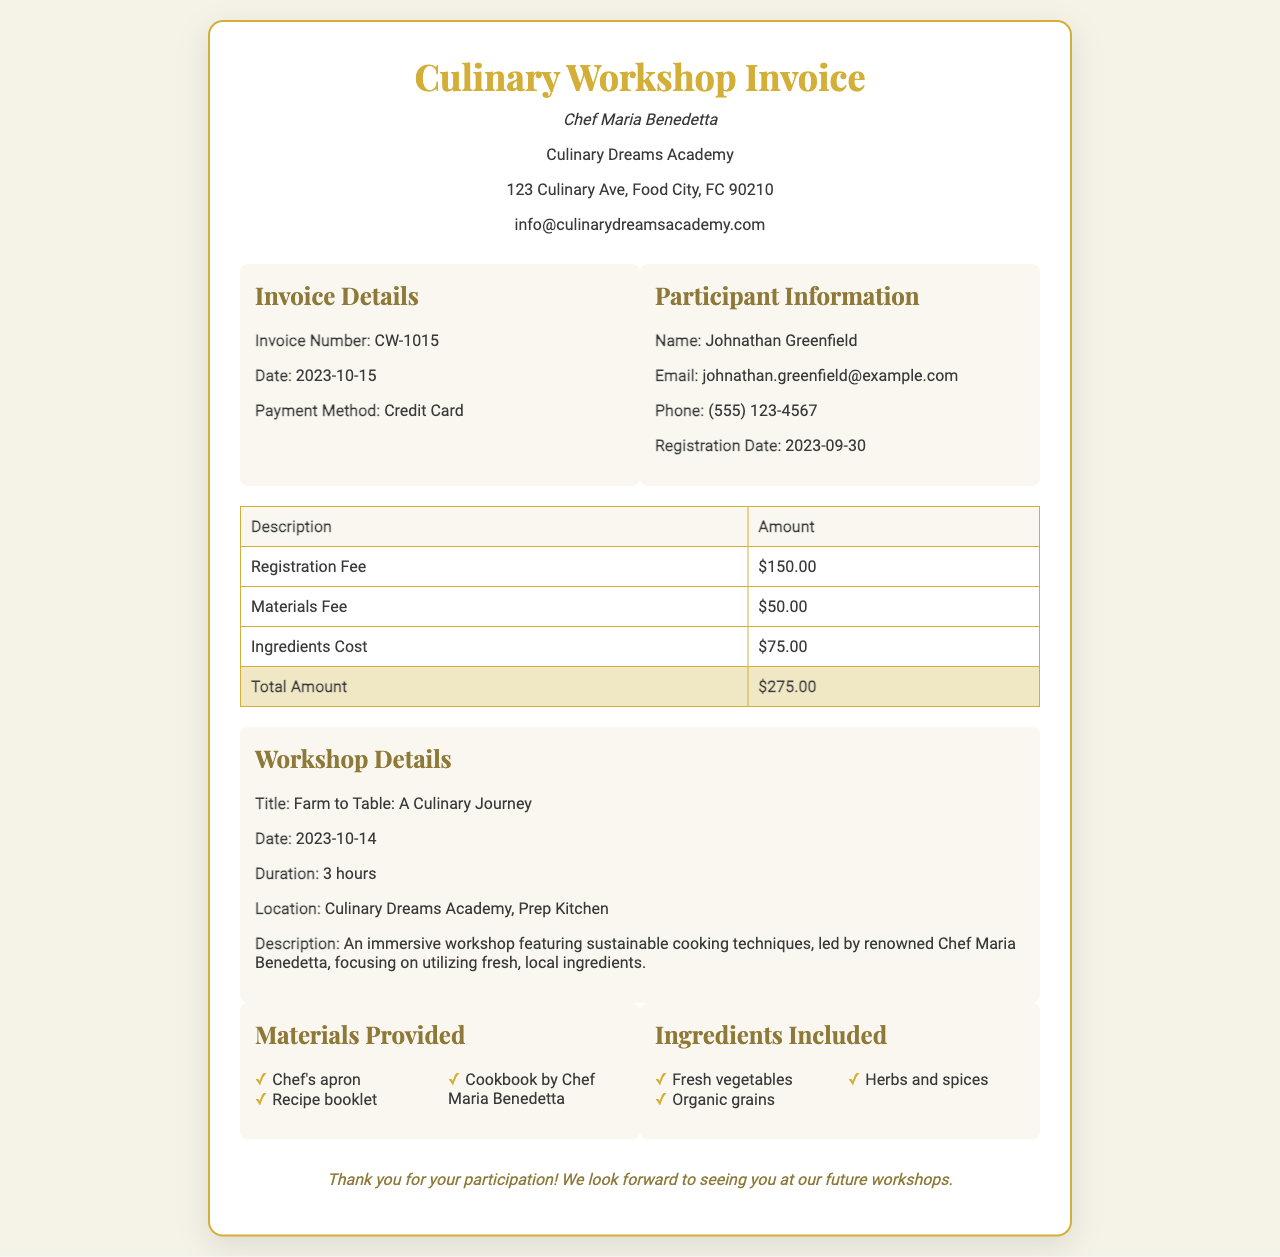What is the invoice number? The invoice number is specifically indicated in the document under "Invoice Details."
Answer: CW-1015 What is the registration fee amount? The registration fee amount is detailed in the fees table as one of the charges.
Answer: $150.00 Who is the renowned chef conducting the workshop? The name of the chef is mentioned in the header of the document.
Answer: Chef Maria Benedetta When was the workshop held? The date of the workshop is provided in the workshop details section.
Answer: 2023-10-14 What items are included in the materials provided? The list of materials is provided under the "Materials Provided" section in the document.
Answer: Chef's apron, Recipe booklet, Cookbook by Chef Maria Benedetta What is the total amount due for the invoice? The total amount can be found at the bottom of the fees table as the final sum of all charges.
Answer: $275.00 What is the method of payment? The method of payment is specified in the invoice details section.
Answer: Credit Card Name one ingredient included in the workshop. The ingredients included are listed under the "Ingredients Included" section.
Answer: Fresh vegetables How long did the workshop last? The duration of the workshop is indicated in the workshop details.
Answer: 3 hours 